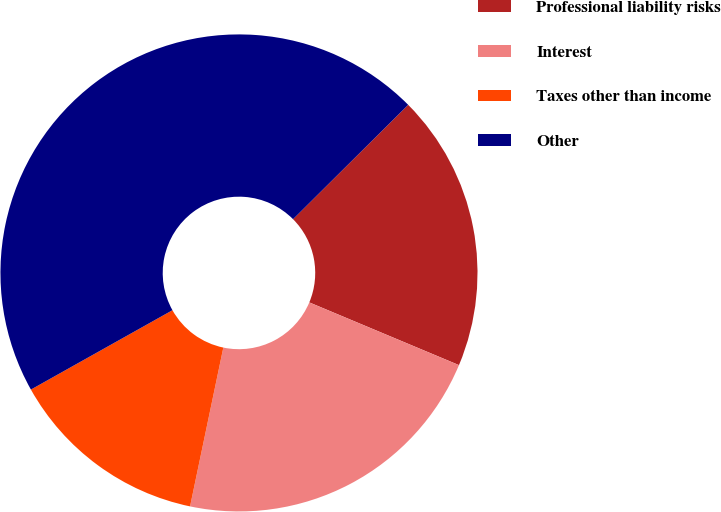<chart> <loc_0><loc_0><loc_500><loc_500><pie_chart><fcel>Professional liability risks<fcel>Interest<fcel>Taxes other than income<fcel>Other<nl><fcel>18.76%<fcel>21.97%<fcel>13.58%<fcel>45.68%<nl></chart> 